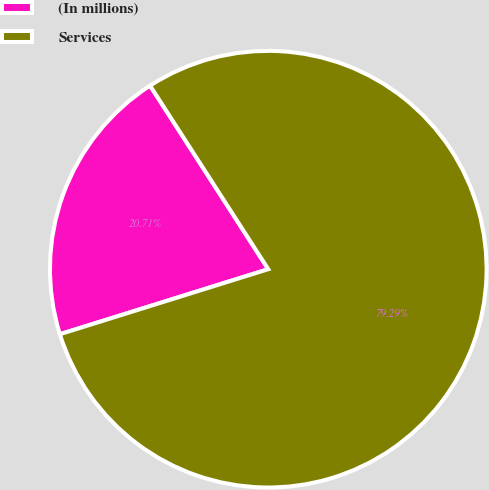Convert chart to OTSL. <chart><loc_0><loc_0><loc_500><loc_500><pie_chart><fcel>(In millions)<fcel>Services<nl><fcel>20.71%<fcel>79.29%<nl></chart> 